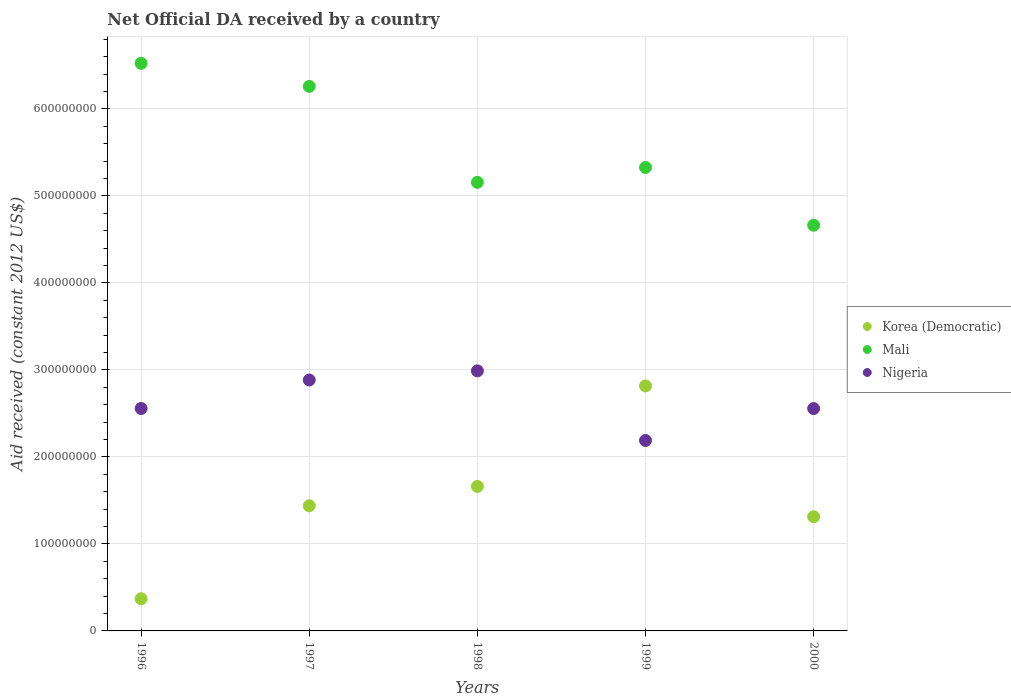Is the number of dotlines equal to the number of legend labels?
Provide a short and direct response. Yes. What is the net official development assistance aid received in Nigeria in 1997?
Make the answer very short. 2.88e+08. Across all years, what is the maximum net official development assistance aid received in Mali?
Offer a very short reply. 6.52e+08. Across all years, what is the minimum net official development assistance aid received in Korea (Democratic)?
Make the answer very short. 3.70e+07. In which year was the net official development assistance aid received in Nigeria minimum?
Make the answer very short. 1999. What is the total net official development assistance aid received in Nigeria in the graph?
Offer a very short reply. 1.32e+09. What is the difference between the net official development assistance aid received in Nigeria in 1997 and that in 2000?
Give a very brief answer. 3.28e+07. What is the difference between the net official development assistance aid received in Nigeria in 1997 and the net official development assistance aid received in Mali in 1999?
Offer a terse response. -2.44e+08. What is the average net official development assistance aid received in Nigeria per year?
Your answer should be very brief. 2.63e+08. In the year 2000, what is the difference between the net official development assistance aid received in Korea (Democratic) and net official development assistance aid received in Mali?
Offer a very short reply. -3.35e+08. In how many years, is the net official development assistance aid received in Mali greater than 660000000 US$?
Keep it short and to the point. 0. What is the ratio of the net official development assistance aid received in Nigeria in 1996 to that in 1998?
Provide a short and direct response. 0.86. Is the difference between the net official development assistance aid received in Korea (Democratic) in 1996 and 1998 greater than the difference between the net official development assistance aid received in Mali in 1996 and 1998?
Provide a short and direct response. No. What is the difference between the highest and the second highest net official development assistance aid received in Nigeria?
Your answer should be compact. 1.04e+07. What is the difference between the highest and the lowest net official development assistance aid received in Mali?
Your answer should be very brief. 1.86e+08. In how many years, is the net official development assistance aid received in Nigeria greater than the average net official development assistance aid received in Nigeria taken over all years?
Your answer should be compact. 2. Is the sum of the net official development assistance aid received in Korea (Democratic) in 1997 and 1998 greater than the maximum net official development assistance aid received in Nigeria across all years?
Your response must be concise. Yes. Is it the case that in every year, the sum of the net official development assistance aid received in Nigeria and net official development assistance aid received in Mali  is greater than the net official development assistance aid received in Korea (Democratic)?
Your response must be concise. Yes. Is the net official development assistance aid received in Nigeria strictly greater than the net official development assistance aid received in Mali over the years?
Make the answer very short. No. Is the net official development assistance aid received in Korea (Democratic) strictly less than the net official development assistance aid received in Nigeria over the years?
Your answer should be compact. No. Does the graph contain any zero values?
Your answer should be compact. No. Where does the legend appear in the graph?
Your answer should be very brief. Center right. How many legend labels are there?
Give a very brief answer. 3. What is the title of the graph?
Provide a short and direct response. Net Official DA received by a country. What is the label or title of the Y-axis?
Give a very brief answer. Aid received (constant 2012 US$). What is the Aid received (constant 2012 US$) of Korea (Democratic) in 1996?
Your answer should be compact. 3.70e+07. What is the Aid received (constant 2012 US$) in Mali in 1996?
Your answer should be compact. 6.52e+08. What is the Aid received (constant 2012 US$) in Nigeria in 1996?
Your response must be concise. 2.56e+08. What is the Aid received (constant 2012 US$) in Korea (Democratic) in 1997?
Offer a terse response. 1.44e+08. What is the Aid received (constant 2012 US$) in Mali in 1997?
Offer a terse response. 6.26e+08. What is the Aid received (constant 2012 US$) of Nigeria in 1997?
Provide a succinct answer. 2.88e+08. What is the Aid received (constant 2012 US$) in Korea (Democratic) in 1998?
Provide a succinct answer. 1.66e+08. What is the Aid received (constant 2012 US$) of Mali in 1998?
Keep it short and to the point. 5.16e+08. What is the Aid received (constant 2012 US$) in Nigeria in 1998?
Give a very brief answer. 2.99e+08. What is the Aid received (constant 2012 US$) in Korea (Democratic) in 1999?
Ensure brevity in your answer.  2.82e+08. What is the Aid received (constant 2012 US$) of Mali in 1999?
Give a very brief answer. 5.33e+08. What is the Aid received (constant 2012 US$) in Nigeria in 1999?
Offer a terse response. 2.19e+08. What is the Aid received (constant 2012 US$) of Korea (Democratic) in 2000?
Your response must be concise. 1.31e+08. What is the Aid received (constant 2012 US$) of Mali in 2000?
Your answer should be very brief. 4.66e+08. What is the Aid received (constant 2012 US$) in Nigeria in 2000?
Keep it short and to the point. 2.56e+08. Across all years, what is the maximum Aid received (constant 2012 US$) of Korea (Democratic)?
Ensure brevity in your answer.  2.82e+08. Across all years, what is the maximum Aid received (constant 2012 US$) in Mali?
Offer a very short reply. 6.52e+08. Across all years, what is the maximum Aid received (constant 2012 US$) of Nigeria?
Ensure brevity in your answer.  2.99e+08. Across all years, what is the minimum Aid received (constant 2012 US$) of Korea (Democratic)?
Provide a short and direct response. 3.70e+07. Across all years, what is the minimum Aid received (constant 2012 US$) in Mali?
Provide a short and direct response. 4.66e+08. Across all years, what is the minimum Aid received (constant 2012 US$) in Nigeria?
Keep it short and to the point. 2.19e+08. What is the total Aid received (constant 2012 US$) in Korea (Democratic) in the graph?
Your answer should be compact. 7.60e+08. What is the total Aid received (constant 2012 US$) of Mali in the graph?
Make the answer very short. 2.79e+09. What is the total Aid received (constant 2012 US$) in Nigeria in the graph?
Offer a very short reply. 1.32e+09. What is the difference between the Aid received (constant 2012 US$) in Korea (Democratic) in 1996 and that in 1997?
Your response must be concise. -1.07e+08. What is the difference between the Aid received (constant 2012 US$) of Mali in 1996 and that in 1997?
Your answer should be compact. 2.65e+07. What is the difference between the Aid received (constant 2012 US$) in Nigeria in 1996 and that in 1997?
Your answer should be compact. -3.28e+07. What is the difference between the Aid received (constant 2012 US$) of Korea (Democratic) in 1996 and that in 1998?
Provide a short and direct response. -1.29e+08. What is the difference between the Aid received (constant 2012 US$) in Mali in 1996 and that in 1998?
Keep it short and to the point. 1.37e+08. What is the difference between the Aid received (constant 2012 US$) of Nigeria in 1996 and that in 1998?
Make the answer very short. -4.32e+07. What is the difference between the Aid received (constant 2012 US$) in Korea (Democratic) in 1996 and that in 1999?
Your answer should be compact. -2.45e+08. What is the difference between the Aid received (constant 2012 US$) in Mali in 1996 and that in 1999?
Ensure brevity in your answer.  1.20e+08. What is the difference between the Aid received (constant 2012 US$) in Nigeria in 1996 and that in 1999?
Make the answer very short. 3.68e+07. What is the difference between the Aid received (constant 2012 US$) in Korea (Democratic) in 1996 and that in 2000?
Offer a very short reply. -9.42e+07. What is the difference between the Aid received (constant 2012 US$) of Mali in 1996 and that in 2000?
Offer a terse response. 1.86e+08. What is the difference between the Aid received (constant 2012 US$) of Nigeria in 1996 and that in 2000?
Offer a terse response. 7.00e+04. What is the difference between the Aid received (constant 2012 US$) of Korea (Democratic) in 1997 and that in 1998?
Your response must be concise. -2.22e+07. What is the difference between the Aid received (constant 2012 US$) of Mali in 1997 and that in 1998?
Your answer should be very brief. 1.10e+08. What is the difference between the Aid received (constant 2012 US$) of Nigeria in 1997 and that in 1998?
Your response must be concise. -1.04e+07. What is the difference between the Aid received (constant 2012 US$) in Korea (Democratic) in 1997 and that in 1999?
Offer a very short reply. -1.38e+08. What is the difference between the Aid received (constant 2012 US$) in Mali in 1997 and that in 1999?
Provide a short and direct response. 9.32e+07. What is the difference between the Aid received (constant 2012 US$) of Nigeria in 1997 and that in 1999?
Your answer should be compact. 6.96e+07. What is the difference between the Aid received (constant 2012 US$) of Korea (Democratic) in 1997 and that in 2000?
Your answer should be very brief. 1.26e+07. What is the difference between the Aid received (constant 2012 US$) in Mali in 1997 and that in 2000?
Offer a terse response. 1.60e+08. What is the difference between the Aid received (constant 2012 US$) of Nigeria in 1997 and that in 2000?
Keep it short and to the point. 3.28e+07. What is the difference between the Aid received (constant 2012 US$) in Korea (Democratic) in 1998 and that in 1999?
Your answer should be very brief. -1.16e+08. What is the difference between the Aid received (constant 2012 US$) of Mali in 1998 and that in 1999?
Ensure brevity in your answer.  -1.71e+07. What is the difference between the Aid received (constant 2012 US$) in Nigeria in 1998 and that in 1999?
Your response must be concise. 8.00e+07. What is the difference between the Aid received (constant 2012 US$) of Korea (Democratic) in 1998 and that in 2000?
Your answer should be compact. 3.48e+07. What is the difference between the Aid received (constant 2012 US$) of Mali in 1998 and that in 2000?
Your answer should be compact. 4.93e+07. What is the difference between the Aid received (constant 2012 US$) in Nigeria in 1998 and that in 2000?
Provide a short and direct response. 4.33e+07. What is the difference between the Aid received (constant 2012 US$) in Korea (Democratic) in 1999 and that in 2000?
Provide a short and direct response. 1.50e+08. What is the difference between the Aid received (constant 2012 US$) of Mali in 1999 and that in 2000?
Keep it short and to the point. 6.64e+07. What is the difference between the Aid received (constant 2012 US$) of Nigeria in 1999 and that in 2000?
Provide a short and direct response. -3.68e+07. What is the difference between the Aid received (constant 2012 US$) of Korea (Democratic) in 1996 and the Aid received (constant 2012 US$) of Mali in 1997?
Offer a terse response. -5.89e+08. What is the difference between the Aid received (constant 2012 US$) in Korea (Democratic) in 1996 and the Aid received (constant 2012 US$) in Nigeria in 1997?
Provide a short and direct response. -2.51e+08. What is the difference between the Aid received (constant 2012 US$) of Mali in 1996 and the Aid received (constant 2012 US$) of Nigeria in 1997?
Provide a succinct answer. 3.64e+08. What is the difference between the Aid received (constant 2012 US$) of Korea (Democratic) in 1996 and the Aid received (constant 2012 US$) of Mali in 1998?
Keep it short and to the point. -4.79e+08. What is the difference between the Aid received (constant 2012 US$) of Korea (Democratic) in 1996 and the Aid received (constant 2012 US$) of Nigeria in 1998?
Provide a short and direct response. -2.62e+08. What is the difference between the Aid received (constant 2012 US$) of Mali in 1996 and the Aid received (constant 2012 US$) of Nigeria in 1998?
Make the answer very short. 3.53e+08. What is the difference between the Aid received (constant 2012 US$) of Korea (Democratic) in 1996 and the Aid received (constant 2012 US$) of Mali in 1999?
Your answer should be compact. -4.96e+08. What is the difference between the Aid received (constant 2012 US$) of Korea (Democratic) in 1996 and the Aid received (constant 2012 US$) of Nigeria in 1999?
Provide a succinct answer. -1.82e+08. What is the difference between the Aid received (constant 2012 US$) of Mali in 1996 and the Aid received (constant 2012 US$) of Nigeria in 1999?
Your answer should be compact. 4.34e+08. What is the difference between the Aid received (constant 2012 US$) in Korea (Democratic) in 1996 and the Aid received (constant 2012 US$) in Mali in 2000?
Provide a succinct answer. -4.29e+08. What is the difference between the Aid received (constant 2012 US$) of Korea (Democratic) in 1996 and the Aid received (constant 2012 US$) of Nigeria in 2000?
Keep it short and to the point. -2.19e+08. What is the difference between the Aid received (constant 2012 US$) in Mali in 1996 and the Aid received (constant 2012 US$) in Nigeria in 2000?
Provide a succinct answer. 3.97e+08. What is the difference between the Aid received (constant 2012 US$) in Korea (Democratic) in 1997 and the Aid received (constant 2012 US$) in Mali in 1998?
Offer a very short reply. -3.72e+08. What is the difference between the Aid received (constant 2012 US$) in Korea (Democratic) in 1997 and the Aid received (constant 2012 US$) in Nigeria in 1998?
Provide a succinct answer. -1.55e+08. What is the difference between the Aid received (constant 2012 US$) of Mali in 1997 and the Aid received (constant 2012 US$) of Nigeria in 1998?
Your response must be concise. 3.27e+08. What is the difference between the Aid received (constant 2012 US$) of Korea (Democratic) in 1997 and the Aid received (constant 2012 US$) of Mali in 1999?
Give a very brief answer. -3.89e+08. What is the difference between the Aid received (constant 2012 US$) of Korea (Democratic) in 1997 and the Aid received (constant 2012 US$) of Nigeria in 1999?
Provide a short and direct response. -7.50e+07. What is the difference between the Aid received (constant 2012 US$) of Mali in 1997 and the Aid received (constant 2012 US$) of Nigeria in 1999?
Keep it short and to the point. 4.07e+08. What is the difference between the Aid received (constant 2012 US$) in Korea (Democratic) in 1997 and the Aid received (constant 2012 US$) in Mali in 2000?
Make the answer very short. -3.22e+08. What is the difference between the Aid received (constant 2012 US$) of Korea (Democratic) in 1997 and the Aid received (constant 2012 US$) of Nigeria in 2000?
Offer a very short reply. -1.12e+08. What is the difference between the Aid received (constant 2012 US$) in Mali in 1997 and the Aid received (constant 2012 US$) in Nigeria in 2000?
Your answer should be compact. 3.70e+08. What is the difference between the Aid received (constant 2012 US$) in Korea (Democratic) in 1998 and the Aid received (constant 2012 US$) in Mali in 1999?
Your answer should be compact. -3.67e+08. What is the difference between the Aid received (constant 2012 US$) in Korea (Democratic) in 1998 and the Aid received (constant 2012 US$) in Nigeria in 1999?
Keep it short and to the point. -5.28e+07. What is the difference between the Aid received (constant 2012 US$) in Mali in 1998 and the Aid received (constant 2012 US$) in Nigeria in 1999?
Provide a succinct answer. 2.97e+08. What is the difference between the Aid received (constant 2012 US$) in Korea (Democratic) in 1998 and the Aid received (constant 2012 US$) in Mali in 2000?
Provide a succinct answer. -3.00e+08. What is the difference between the Aid received (constant 2012 US$) of Korea (Democratic) in 1998 and the Aid received (constant 2012 US$) of Nigeria in 2000?
Keep it short and to the point. -8.95e+07. What is the difference between the Aid received (constant 2012 US$) of Mali in 1998 and the Aid received (constant 2012 US$) of Nigeria in 2000?
Offer a terse response. 2.60e+08. What is the difference between the Aid received (constant 2012 US$) in Korea (Democratic) in 1999 and the Aid received (constant 2012 US$) in Mali in 2000?
Offer a terse response. -1.85e+08. What is the difference between the Aid received (constant 2012 US$) of Korea (Democratic) in 1999 and the Aid received (constant 2012 US$) of Nigeria in 2000?
Your answer should be very brief. 2.60e+07. What is the difference between the Aid received (constant 2012 US$) of Mali in 1999 and the Aid received (constant 2012 US$) of Nigeria in 2000?
Give a very brief answer. 2.77e+08. What is the average Aid received (constant 2012 US$) of Korea (Democratic) per year?
Your answer should be very brief. 1.52e+08. What is the average Aid received (constant 2012 US$) in Mali per year?
Your answer should be compact. 5.59e+08. What is the average Aid received (constant 2012 US$) of Nigeria per year?
Make the answer very short. 2.63e+08. In the year 1996, what is the difference between the Aid received (constant 2012 US$) in Korea (Democratic) and Aid received (constant 2012 US$) in Mali?
Keep it short and to the point. -6.15e+08. In the year 1996, what is the difference between the Aid received (constant 2012 US$) of Korea (Democratic) and Aid received (constant 2012 US$) of Nigeria?
Keep it short and to the point. -2.19e+08. In the year 1996, what is the difference between the Aid received (constant 2012 US$) in Mali and Aid received (constant 2012 US$) in Nigeria?
Make the answer very short. 3.97e+08. In the year 1997, what is the difference between the Aid received (constant 2012 US$) of Korea (Democratic) and Aid received (constant 2012 US$) of Mali?
Provide a succinct answer. -4.82e+08. In the year 1997, what is the difference between the Aid received (constant 2012 US$) of Korea (Democratic) and Aid received (constant 2012 US$) of Nigeria?
Ensure brevity in your answer.  -1.45e+08. In the year 1997, what is the difference between the Aid received (constant 2012 US$) of Mali and Aid received (constant 2012 US$) of Nigeria?
Keep it short and to the point. 3.37e+08. In the year 1998, what is the difference between the Aid received (constant 2012 US$) in Korea (Democratic) and Aid received (constant 2012 US$) in Mali?
Provide a succinct answer. -3.50e+08. In the year 1998, what is the difference between the Aid received (constant 2012 US$) in Korea (Democratic) and Aid received (constant 2012 US$) in Nigeria?
Offer a terse response. -1.33e+08. In the year 1998, what is the difference between the Aid received (constant 2012 US$) in Mali and Aid received (constant 2012 US$) in Nigeria?
Provide a short and direct response. 2.17e+08. In the year 1999, what is the difference between the Aid received (constant 2012 US$) of Korea (Democratic) and Aid received (constant 2012 US$) of Mali?
Give a very brief answer. -2.51e+08. In the year 1999, what is the difference between the Aid received (constant 2012 US$) in Korea (Democratic) and Aid received (constant 2012 US$) in Nigeria?
Ensure brevity in your answer.  6.27e+07. In the year 1999, what is the difference between the Aid received (constant 2012 US$) in Mali and Aid received (constant 2012 US$) in Nigeria?
Your answer should be very brief. 3.14e+08. In the year 2000, what is the difference between the Aid received (constant 2012 US$) of Korea (Democratic) and Aid received (constant 2012 US$) of Mali?
Your answer should be very brief. -3.35e+08. In the year 2000, what is the difference between the Aid received (constant 2012 US$) in Korea (Democratic) and Aid received (constant 2012 US$) in Nigeria?
Keep it short and to the point. -1.24e+08. In the year 2000, what is the difference between the Aid received (constant 2012 US$) of Mali and Aid received (constant 2012 US$) of Nigeria?
Ensure brevity in your answer.  2.11e+08. What is the ratio of the Aid received (constant 2012 US$) in Korea (Democratic) in 1996 to that in 1997?
Ensure brevity in your answer.  0.26. What is the ratio of the Aid received (constant 2012 US$) in Mali in 1996 to that in 1997?
Provide a succinct answer. 1.04. What is the ratio of the Aid received (constant 2012 US$) of Nigeria in 1996 to that in 1997?
Give a very brief answer. 0.89. What is the ratio of the Aid received (constant 2012 US$) of Korea (Democratic) in 1996 to that in 1998?
Offer a terse response. 0.22. What is the ratio of the Aid received (constant 2012 US$) in Mali in 1996 to that in 1998?
Offer a terse response. 1.27. What is the ratio of the Aid received (constant 2012 US$) of Nigeria in 1996 to that in 1998?
Keep it short and to the point. 0.86. What is the ratio of the Aid received (constant 2012 US$) in Korea (Democratic) in 1996 to that in 1999?
Keep it short and to the point. 0.13. What is the ratio of the Aid received (constant 2012 US$) of Mali in 1996 to that in 1999?
Your response must be concise. 1.22. What is the ratio of the Aid received (constant 2012 US$) in Nigeria in 1996 to that in 1999?
Ensure brevity in your answer.  1.17. What is the ratio of the Aid received (constant 2012 US$) in Korea (Democratic) in 1996 to that in 2000?
Offer a terse response. 0.28. What is the ratio of the Aid received (constant 2012 US$) of Mali in 1996 to that in 2000?
Provide a succinct answer. 1.4. What is the ratio of the Aid received (constant 2012 US$) in Korea (Democratic) in 1997 to that in 1998?
Provide a short and direct response. 0.87. What is the ratio of the Aid received (constant 2012 US$) of Mali in 1997 to that in 1998?
Provide a short and direct response. 1.21. What is the ratio of the Aid received (constant 2012 US$) of Korea (Democratic) in 1997 to that in 1999?
Give a very brief answer. 0.51. What is the ratio of the Aid received (constant 2012 US$) of Mali in 1997 to that in 1999?
Give a very brief answer. 1.17. What is the ratio of the Aid received (constant 2012 US$) of Nigeria in 1997 to that in 1999?
Ensure brevity in your answer.  1.32. What is the ratio of the Aid received (constant 2012 US$) of Korea (Democratic) in 1997 to that in 2000?
Provide a short and direct response. 1.1. What is the ratio of the Aid received (constant 2012 US$) of Mali in 1997 to that in 2000?
Ensure brevity in your answer.  1.34. What is the ratio of the Aid received (constant 2012 US$) of Nigeria in 1997 to that in 2000?
Provide a short and direct response. 1.13. What is the ratio of the Aid received (constant 2012 US$) of Korea (Democratic) in 1998 to that in 1999?
Give a very brief answer. 0.59. What is the ratio of the Aid received (constant 2012 US$) of Mali in 1998 to that in 1999?
Make the answer very short. 0.97. What is the ratio of the Aid received (constant 2012 US$) in Nigeria in 1998 to that in 1999?
Give a very brief answer. 1.37. What is the ratio of the Aid received (constant 2012 US$) in Korea (Democratic) in 1998 to that in 2000?
Keep it short and to the point. 1.27. What is the ratio of the Aid received (constant 2012 US$) in Mali in 1998 to that in 2000?
Your answer should be compact. 1.11. What is the ratio of the Aid received (constant 2012 US$) of Nigeria in 1998 to that in 2000?
Your answer should be compact. 1.17. What is the ratio of the Aid received (constant 2012 US$) of Korea (Democratic) in 1999 to that in 2000?
Ensure brevity in your answer.  2.15. What is the ratio of the Aid received (constant 2012 US$) of Mali in 1999 to that in 2000?
Your answer should be very brief. 1.14. What is the ratio of the Aid received (constant 2012 US$) in Nigeria in 1999 to that in 2000?
Provide a succinct answer. 0.86. What is the difference between the highest and the second highest Aid received (constant 2012 US$) of Korea (Democratic)?
Make the answer very short. 1.16e+08. What is the difference between the highest and the second highest Aid received (constant 2012 US$) of Mali?
Keep it short and to the point. 2.65e+07. What is the difference between the highest and the second highest Aid received (constant 2012 US$) of Nigeria?
Provide a short and direct response. 1.04e+07. What is the difference between the highest and the lowest Aid received (constant 2012 US$) in Korea (Democratic)?
Offer a very short reply. 2.45e+08. What is the difference between the highest and the lowest Aid received (constant 2012 US$) of Mali?
Your answer should be very brief. 1.86e+08. What is the difference between the highest and the lowest Aid received (constant 2012 US$) in Nigeria?
Ensure brevity in your answer.  8.00e+07. 